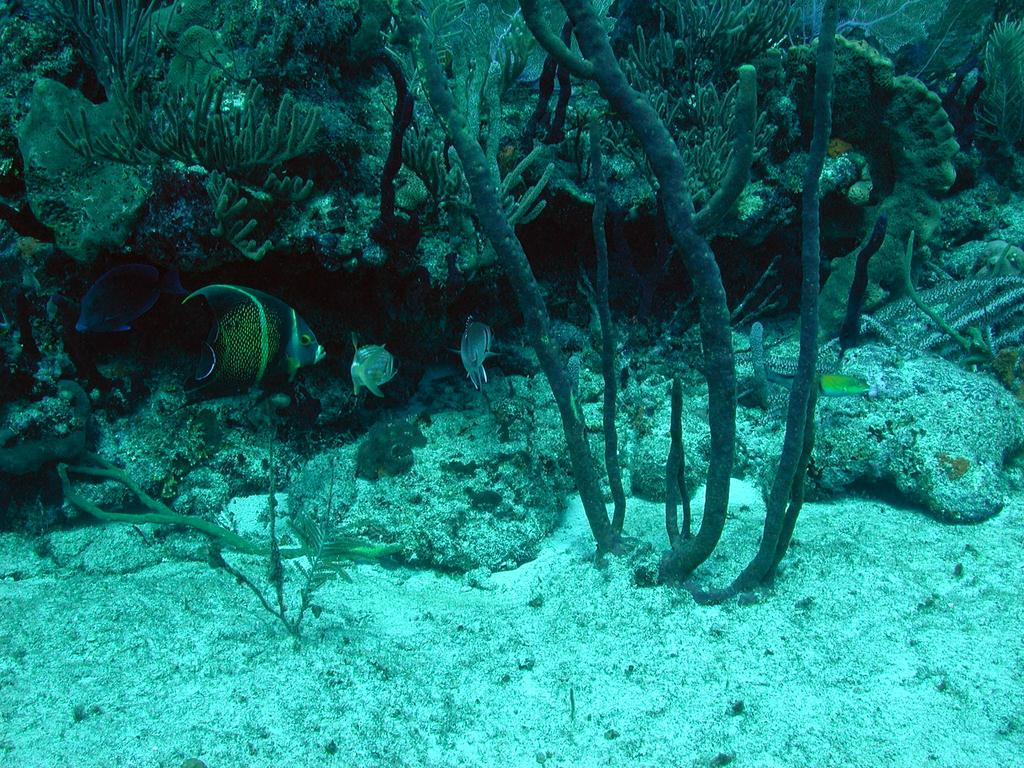What type of environment is depicted in the image? The image depicts an underwater environment. What living organisms can be seen in the image? There are fishes visible in the image. What type of vegetation is present underwater in the image? There are plants and bushes underwater in the image. What type of toothbrush is visible in the image? There is no toothbrush present in the image; it depicts an underwater environment with fishes, plants, and bushes. 